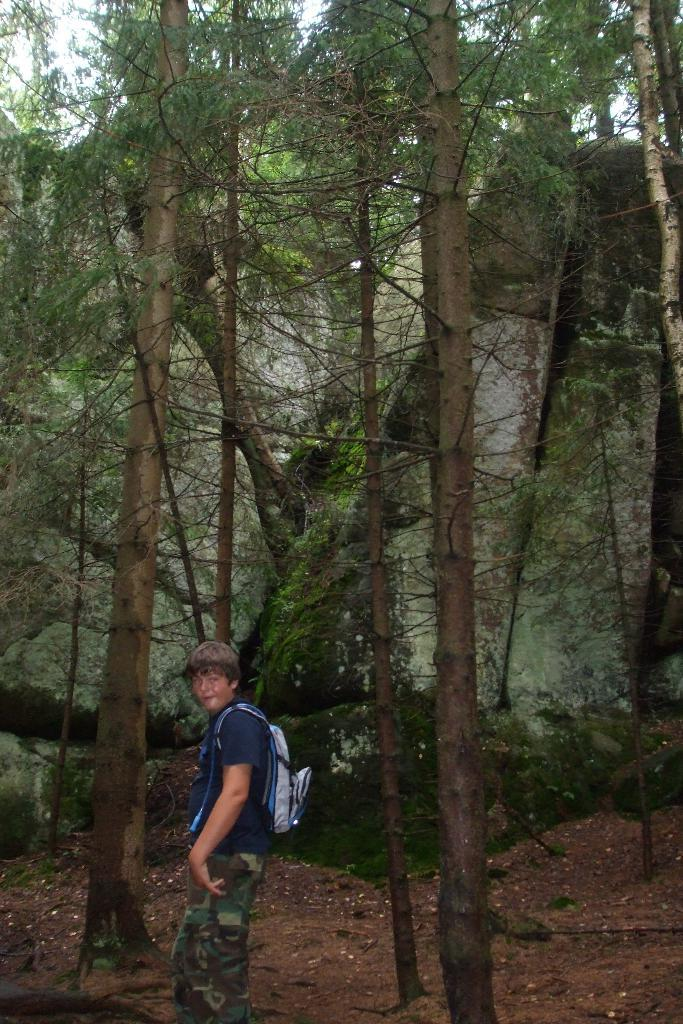What type of vegetation can be seen in the image? There are trees in the image. What is the boy wearing in the image? The boy is wearing a bag in the image. What is present at the bottom of the image? Soil is visible at the bottom of the image. What can be seen in the distance in the image? There is a mountain in the background of the image. How many legs does the robin have in the image? There is no robin present in the image, so it is not possible to determine the number of legs it might have. What type of bubble is floating near the boy in the image? There is no bubble present in the image. 